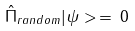Convert formula to latex. <formula><loc_0><loc_0><loc_500><loc_500>\hat { \Pi } _ { r a n d o m } | \psi > \, = \, 0</formula> 